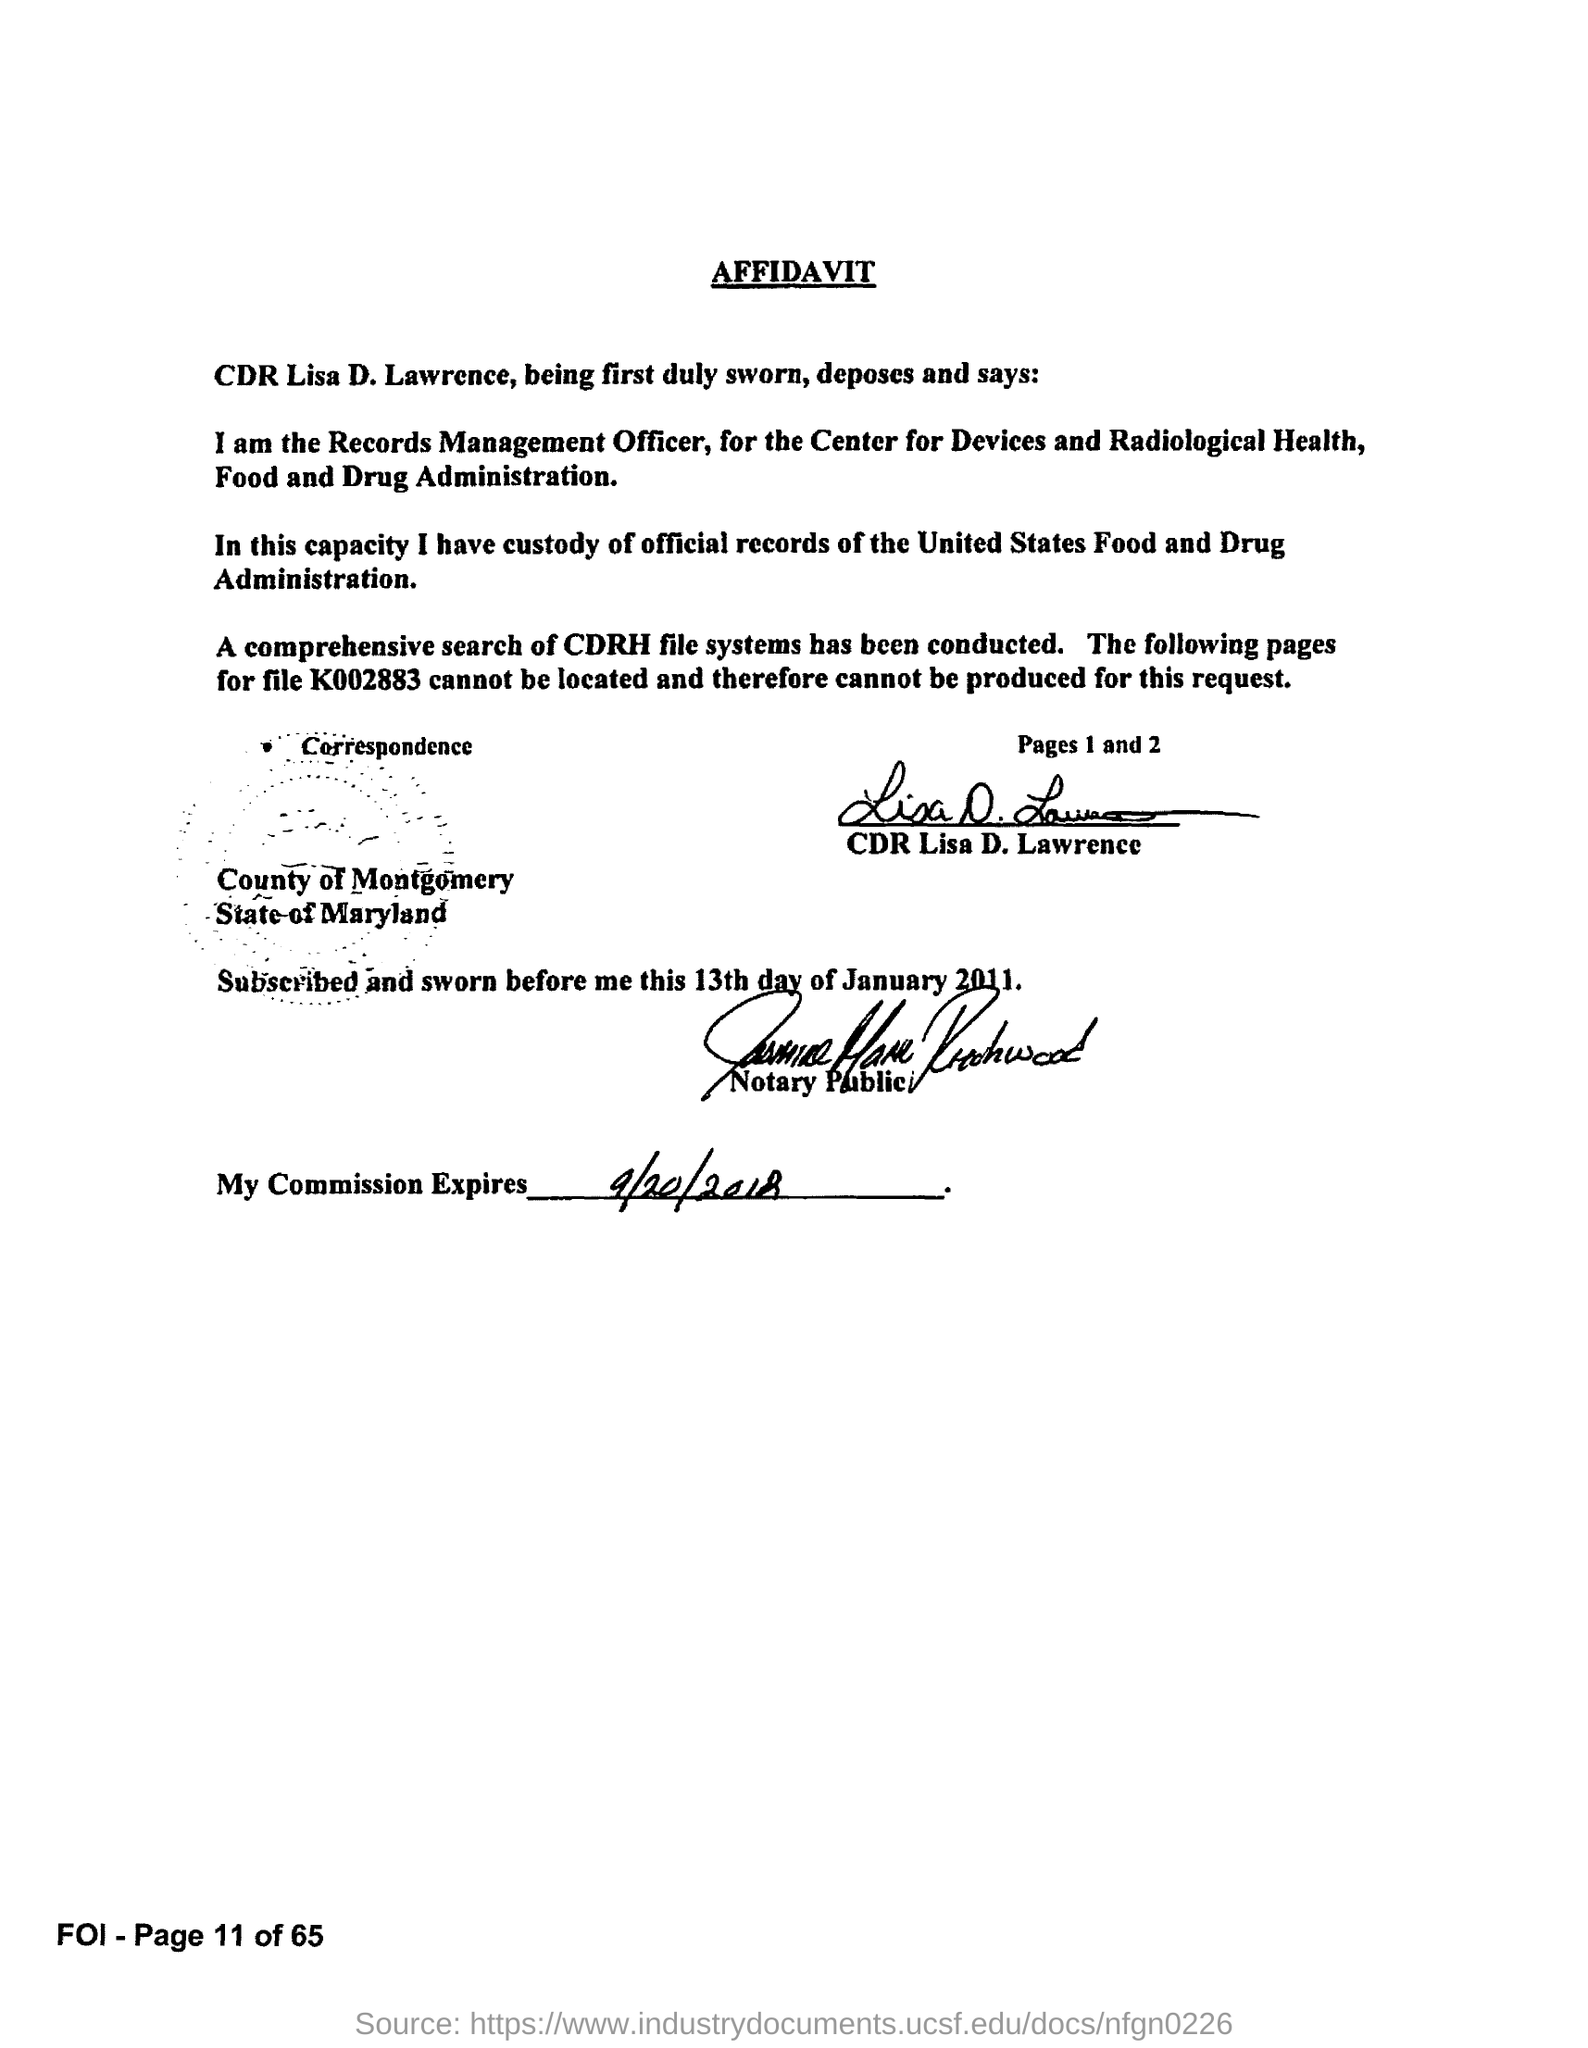What type of document is this?
Give a very brief answer. AFFIDAVIT. Who has signed the affidavit?
Your answer should be very brief. CDR Lisa D. Lawrence. 